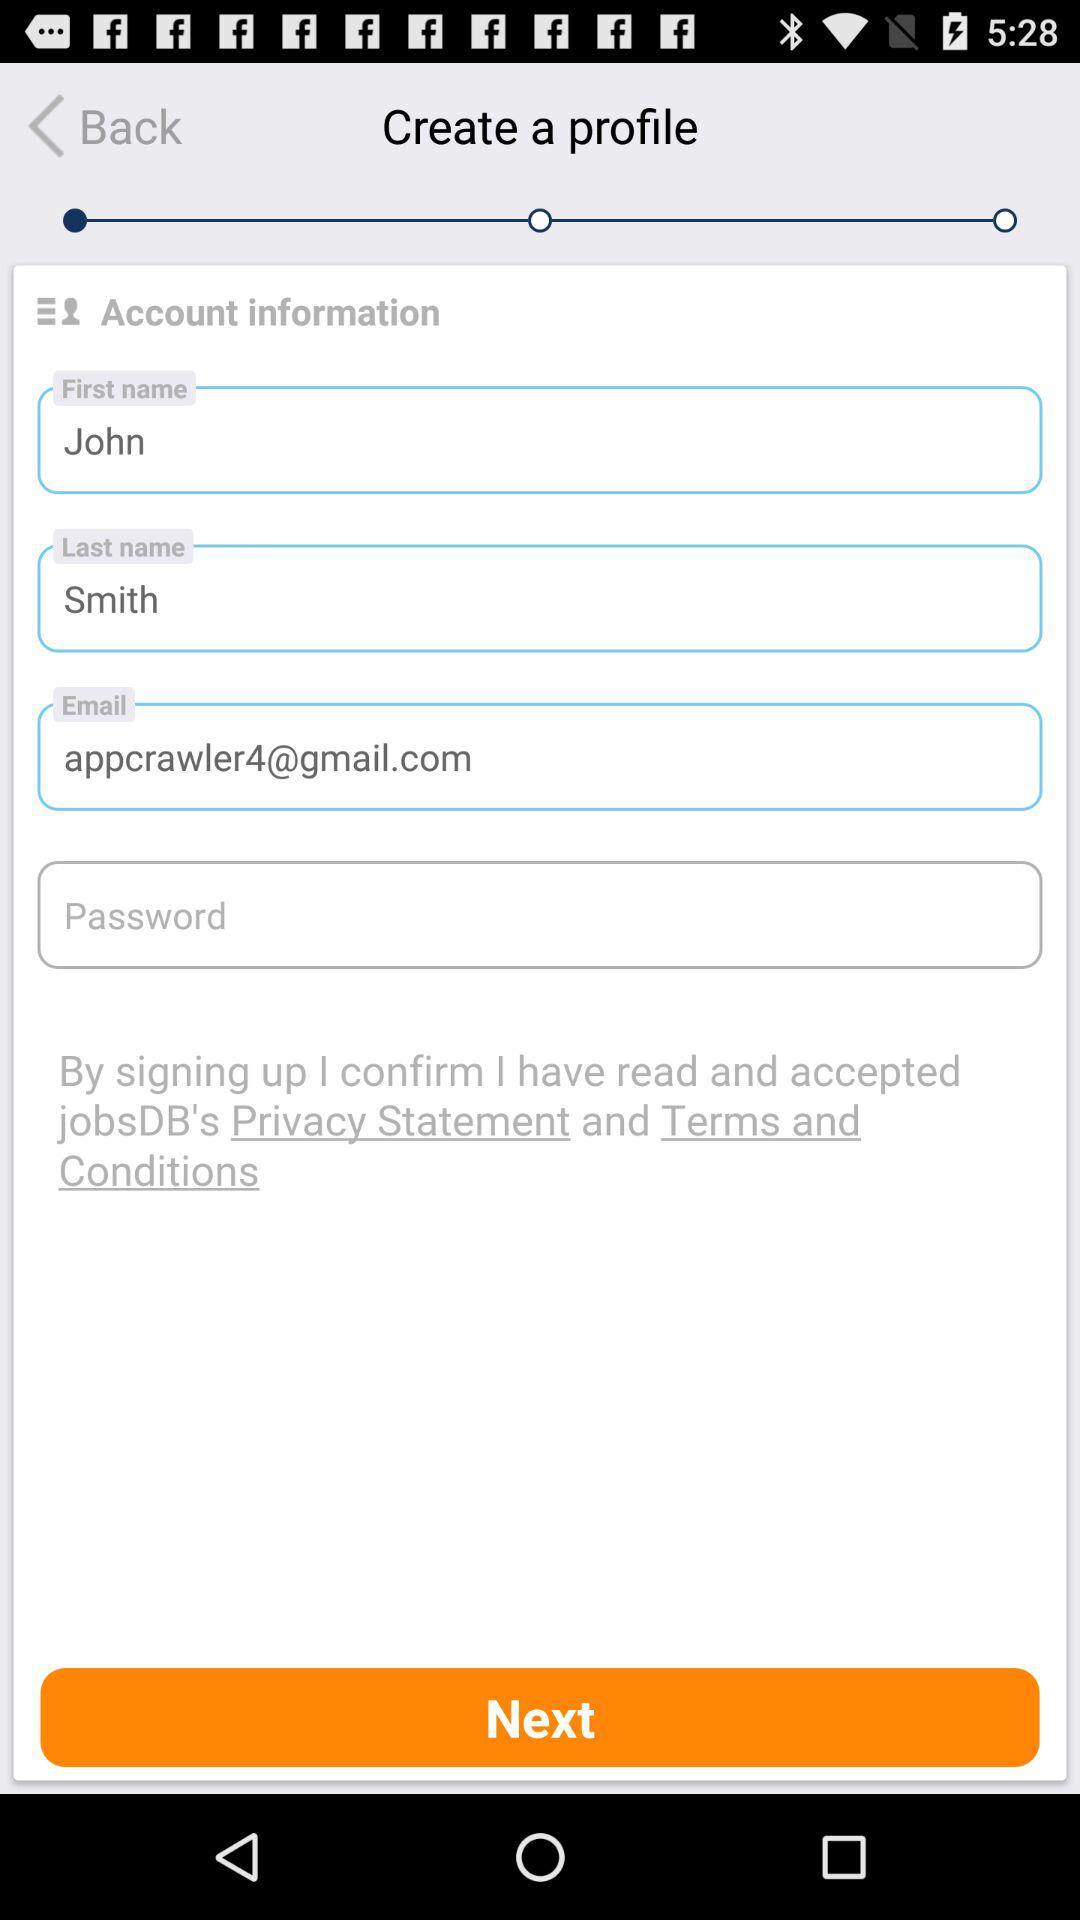What's the email address? The email address is appcrawler4@gmail.com. 